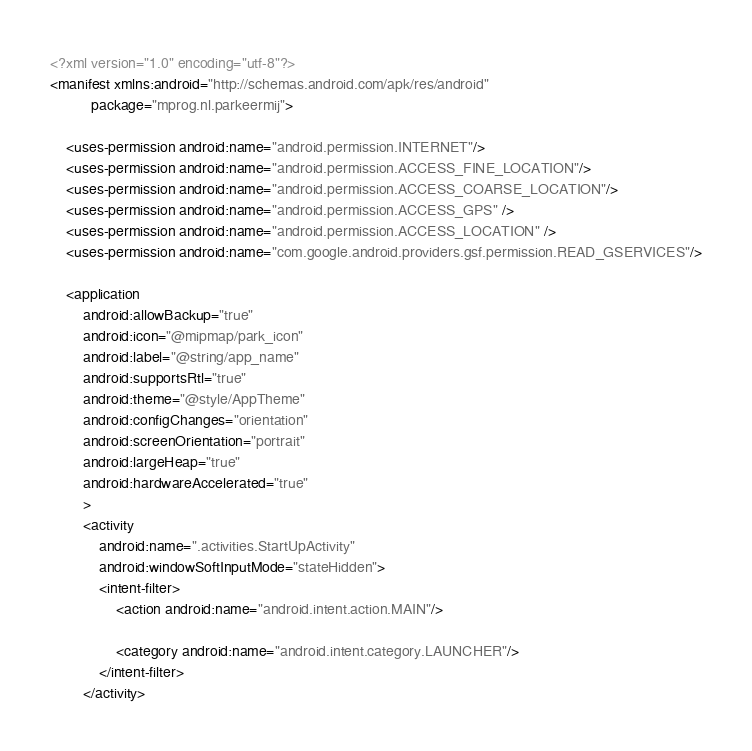Convert code to text. <code><loc_0><loc_0><loc_500><loc_500><_XML_><?xml version="1.0" encoding="utf-8"?>
<manifest xmlns:android="http://schemas.android.com/apk/res/android"
          package="mprog.nl.parkeermij">

    <uses-permission android:name="android.permission.INTERNET"/>
    <uses-permission android:name="android.permission.ACCESS_FINE_LOCATION"/>
    <uses-permission android:name="android.permission.ACCESS_COARSE_LOCATION"/>
    <uses-permission android:name="android.permission.ACCESS_GPS" />
    <uses-permission android:name="android.permission.ACCESS_LOCATION" />
    <uses-permission android:name="com.google.android.providers.gsf.permission.READ_GSERVICES"/>

    <application
        android:allowBackup="true"
        android:icon="@mipmap/park_icon"
        android:label="@string/app_name"
        android:supportsRtl="true"
        android:theme="@style/AppTheme"
        android:configChanges="orientation"
        android:screenOrientation="portrait"
        android:largeHeap="true"
        android:hardwareAccelerated="true"
        >
        <activity
            android:name=".activities.StartUpActivity"
            android:windowSoftInputMode="stateHidden">
            <intent-filter>
                <action android:name="android.intent.action.MAIN"/>

                <category android:name="android.intent.category.LAUNCHER"/>
            </intent-filter>
        </activity>
</code> 